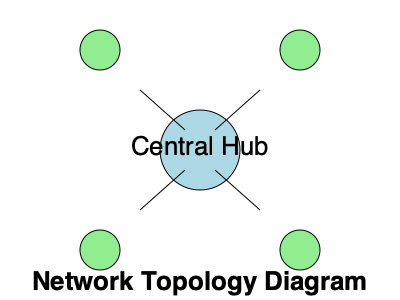Identify the network topology shown in the diagram above. What are the potential advantages and disadvantages of this topology for a small office network? To identify the network topology and understand its advantages and disadvantages, let's follow these steps:

1. Observe the diagram:
   - There is a central node labeled "Central Hub"
   - Four other nodes are connected directly to the central hub
   - No connections exist between the outer nodes

2. Identify the topology:
   This configuration represents a Star topology. In a star topology, all devices are connected to a central hub or switch.

3. Advantages of Star topology:
   a) Easy to install and configure: Adding or removing devices is simple
   b) Centralized management: All traffic passes through the central hub
   c) Fault isolation: If one connection fails, others remain unaffected
   d) Good performance: Direct connections to the hub reduce network congestion

4. Disadvantages of Star topology:
   a) Single point of failure: If the central hub fails, the entire network goes down
   b) Limited scalability: The number of ports on the central hub limits network size
   c) Higher cost: Requires more cabling compared to some other topologies
   d) Dependency on central hub: Network performance depends on the hub's capabilities

5. Relevance to a small office network:
   - Suitable for small to medium-sized offices due to easy management and troubleshooting
   - Cost-effective for smaller networks but may become expensive as the network grows
   - Provides good performance for typical office applications and file sharing

In summary, the star topology offers a balance of performance, manageability, and fault tolerance, making it a popular choice for small office networks despite the potential single point of failure.
Answer: Star topology; Advantages: easy installation, centralized management, fault isolation; Disadvantages: single point of failure, limited scalability 